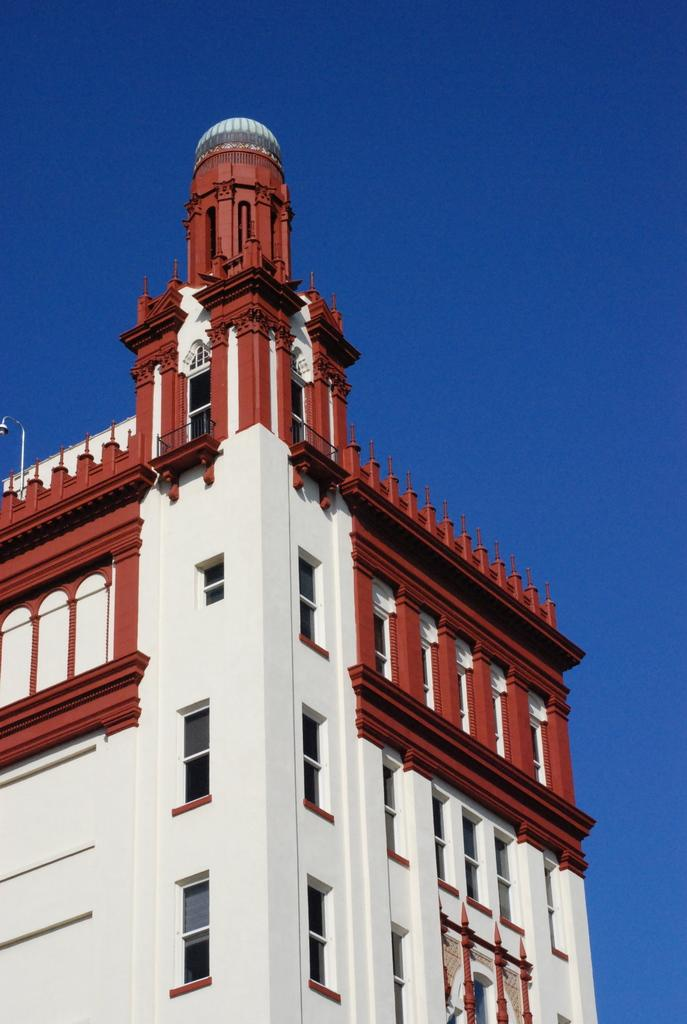What structure is located on the left side of the image? There is a building on the left side of the image. What is visible above the building in the image? The sky is visible above the building in the image. How many cows are grazing in front of the building in the image? There are no cows present in the image; it only features a building and the sky. 